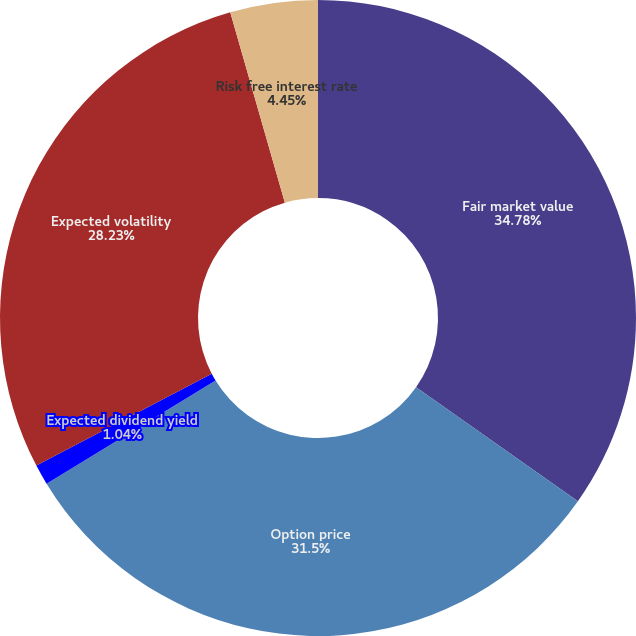Convert chart. <chart><loc_0><loc_0><loc_500><loc_500><pie_chart><fcel>Fair market value<fcel>Option price<fcel>Expected dividend yield<fcel>Expected volatility<fcel>Risk free interest rate<nl><fcel>34.77%<fcel>31.5%<fcel>1.04%<fcel>28.23%<fcel>4.45%<nl></chart> 